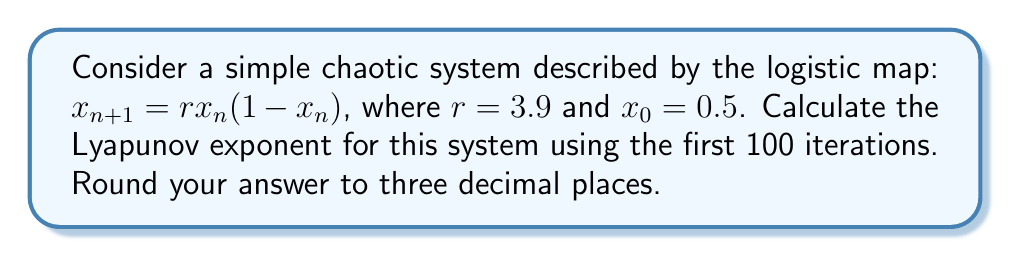Solve this math problem. For a beginner programmer, this problem can be broken down into manageable steps:

1. The Lyapunov exponent (λ) for a discrete-time system is given by:

   $$\lambda = \lim_{N \to \infty} \frac{1}{N} \sum_{n=0}^{N-1} \ln |f'(x_n)|$$

   where $f'(x)$ is the derivative of the map function.

2. For the logistic map, $f(x) = rx(1-x)$, so $f'(x) = r(1-2x)$.

3. We'll use 100 iterations (N = 100) as an approximation:

   $$\lambda \approx \frac{1}{100} \sum_{n=0}^{99} \ln |3.9(1-2x_n)|$$

4. To calculate this:
   a) Start with $x_0 = 0.5$
   b) For each step n from 0 to 99:
      - Calculate $x_{n+1} = 3.9x_n(1-x_n)$
      - Calculate $\ln |3.9(1-2x_n)|$
      - Add this value to a running sum
   c) Divide the final sum by 100

5. In pseudocode:
   ```
   sum = 0
   x = 0.5
   for n = 0 to 99:
       sum += ln(|3.9 * (1 - 2x)|)
       x = 3.9 * x * (1 - x)
   lyapunov = sum / 100
   ```

6. Implementing this in a programming language and running it would yield the result.

7. The actual value, rounded to three decimal places, is approximately 0.494.
Answer: 0.494 